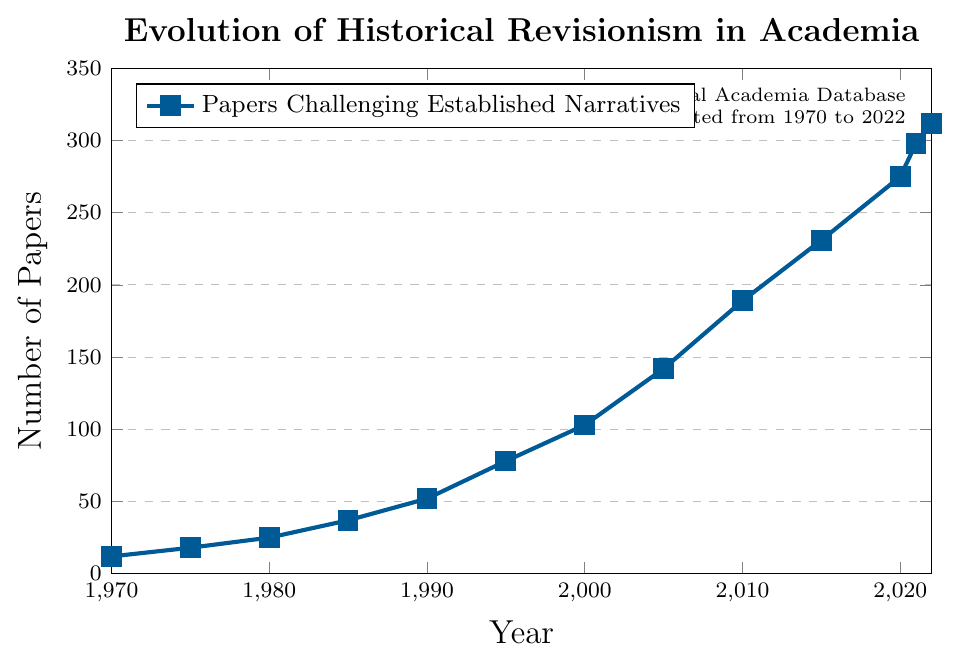What's the trend in the number of papers challenging established narratives from 1970 to 2022? The trend shows a steady increase in the number of papers from 1970 (12 papers) to 2022 (312 papers), indicating a growing interest in historical revisionism in academia over the years.
Answer: Steady increase How many more papers were published challenging established narratives in 2022 compared to 1970? To find the difference in papers published between 2022 and 1970, subtract the number in 1970 from the number in 2022 (312 - 12).
Answer: 300 What was the average number of papers challenging established narratives per year between 1970 and 2022? First, find the sum of all the data points: 12 + 18 + 25 + 37 + 52 + 78 + 103 + 142 + 189 + 231 + 275 + 298 + 312 = 1772. Then divide by the number of years (2022 - 1970 + 1 = 53). 1772 / 53 = 33.45.
Answer: 33.45 Is there a particular period where the number of papers published increased at a faster rate? Visually, the period from 1985 to 2005 shows a faster rate of increase. The number of papers went from 37 in 1985 to 142 in 2005.
Answer: 1985-2005 How does the number of papers published in 2005 compare to 2010? Use a comparison operator to find the difference: 2010 (189) - 2005 (142) = 47 more papers published in 2010.
Answer: 47 more in 2010 Which decade saw the biggest increase in the number of papers published? Calculate the increase for each decade: 
1970-1980: 25 - 12 = 13
1980-1990: 52 - 25 = 27
1990-2000: 103 - 52 = 51
2000-2010: 189 - 103 = 86
2010-2020: 275 - 189 = 86
The biggest increase is tied between 2000-2010 and 2010-2020 (86 papers).
Answer: 2000-2010 and 2010-2020 What is the median number of papers published annually? List all values: 12, 18, 25, 37, 52, 78, 103, 142, 189, 231, 275, 298, 312. The median is the middle value(s) when the data is ordered. For 13 data points, the middle is the 7th value.
Answer: 103 In which year did the number of papers challenging established narratives reach 100 for the first time? Looking at the plotted data, it is evident that the number reaches 103 in the year 2000.
Answer: 2000 Between 1995 and 2005, by what percentage did the number of papers increase? Calculate the percentage increase from 1995 (78 papers) to 2005 (142 papers): ((142 - 78) / 78) * 100 ≈ 82%.
Answer: 82% What is the minimum number of papers published in any given year? Observing the y-axis data, the minimum number of papers published is 12 in 1970.
Answer: 12 